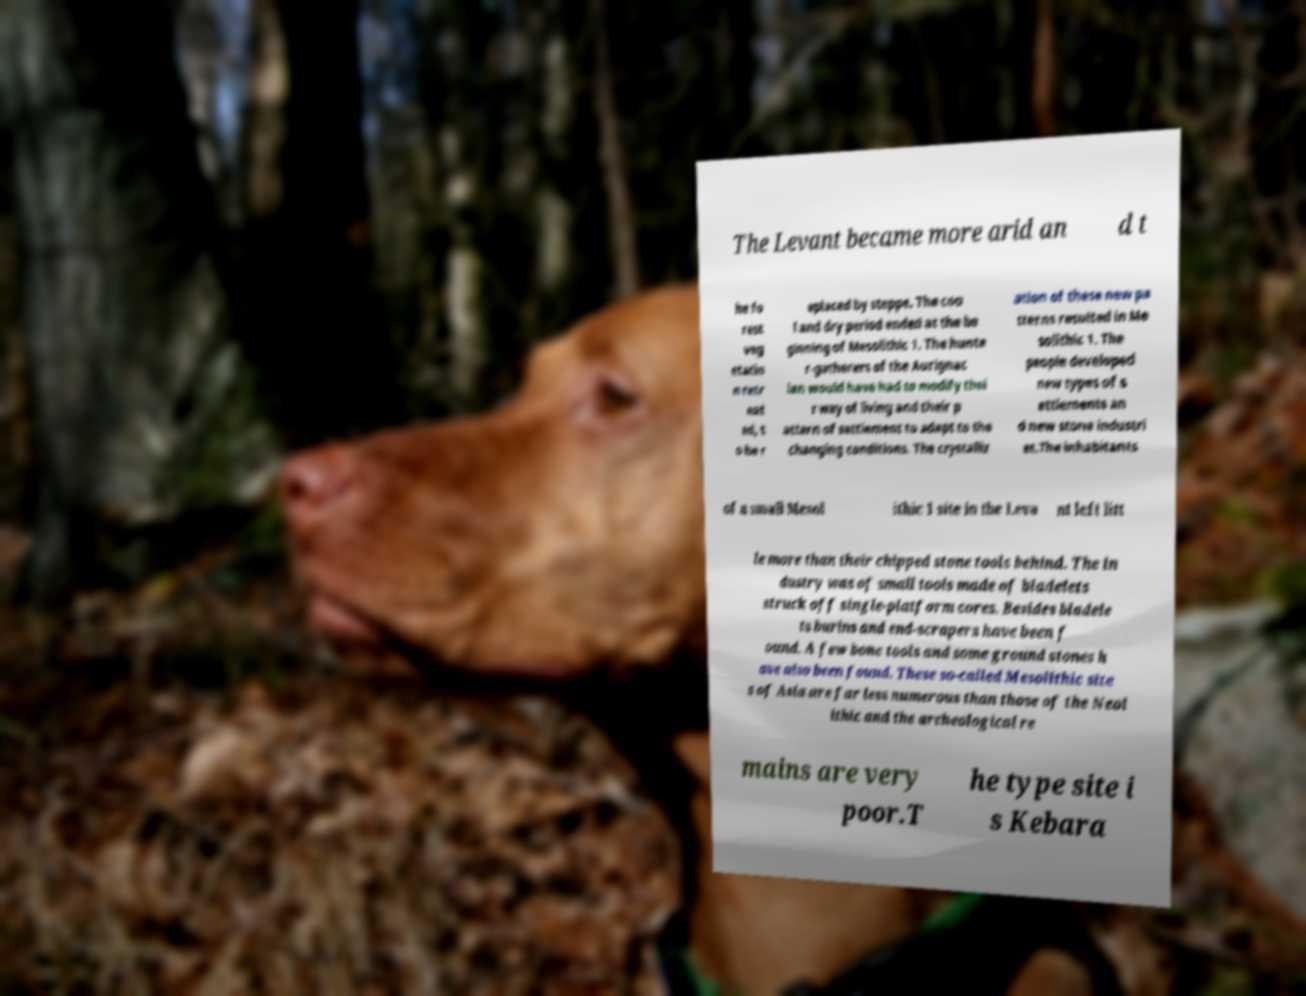Can you read and provide the text displayed in the image?This photo seems to have some interesting text. Can you extract and type it out for me? The Levant became more arid an d t he fo rest veg etatio n retr eat ed, t o be r eplaced by steppe. The coo l and dry period ended at the be ginning of Mesolithic 1. The hunte r-gatherers of the Aurignac ian would have had to modify thei r way of living and their p attern of settlement to adapt to the changing conditions. The crystalliz ation of these new pa tterns resulted in Me solithic 1. The people developed new types of s ettlements an d new stone industri es.The inhabitants of a small Mesol ithic 1 site in the Leva nt left litt le more than their chipped stone tools behind. The in dustry was of small tools made of bladelets struck off single-platform cores. Besides bladele ts burins and end-scrapers have been f ound. A few bone tools and some ground stones h ave also been found. These so-called Mesolithic site s of Asia are far less numerous than those of the Neol ithic and the archeological re mains are very poor.T he type site i s Kebara 